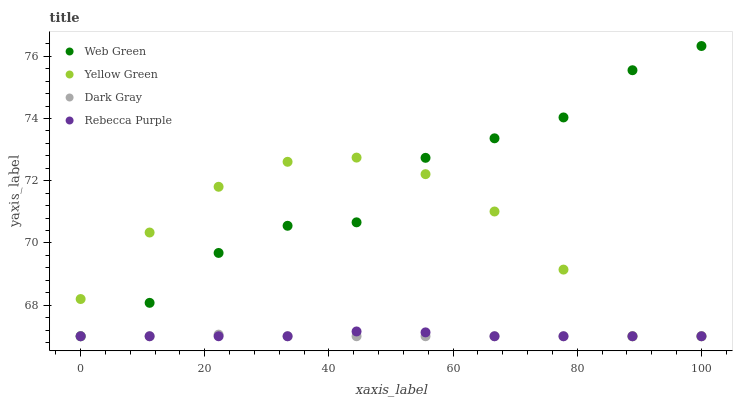Does Dark Gray have the minimum area under the curve?
Answer yes or no. Yes. Does Web Green have the maximum area under the curve?
Answer yes or no. Yes. Does Yellow Green have the minimum area under the curve?
Answer yes or no. No. Does Yellow Green have the maximum area under the curve?
Answer yes or no. No. Is Dark Gray the smoothest?
Answer yes or no. Yes. Is Web Green the roughest?
Answer yes or no. Yes. Is Yellow Green the smoothest?
Answer yes or no. No. Is Yellow Green the roughest?
Answer yes or no. No. Does Dark Gray have the lowest value?
Answer yes or no. Yes. Does Web Green have the highest value?
Answer yes or no. Yes. Does Yellow Green have the highest value?
Answer yes or no. No. Does Web Green intersect Rebecca Purple?
Answer yes or no. Yes. Is Web Green less than Rebecca Purple?
Answer yes or no. No. Is Web Green greater than Rebecca Purple?
Answer yes or no. No. 